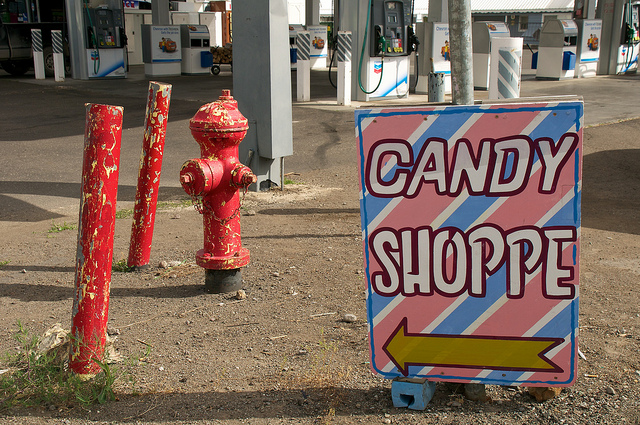Please identify all text content in this image. CANDY SHOPPE 